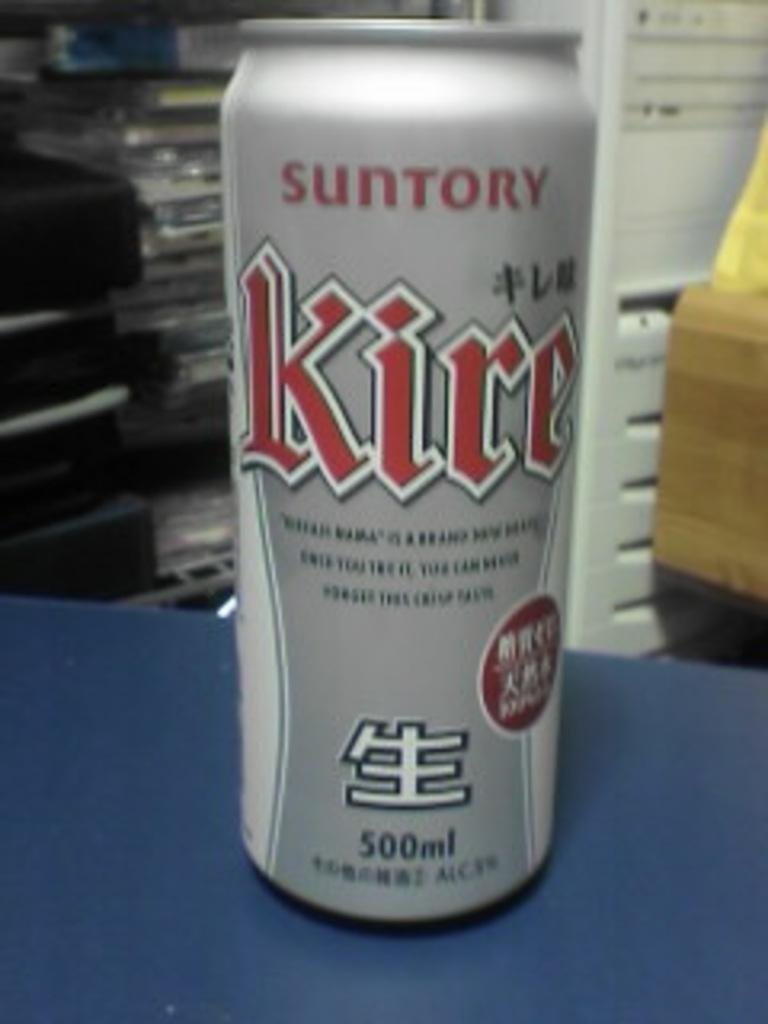Provide a one-sentence caption for the provided image. A canned beverage by Suntory has a volume of 500 mL. 